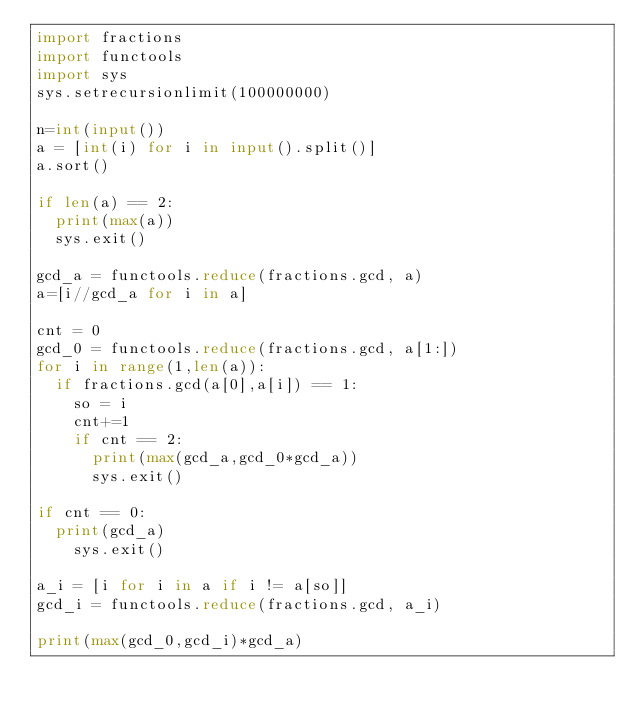<code> <loc_0><loc_0><loc_500><loc_500><_Python_>import fractions
import functools
import sys
sys.setrecursionlimit(100000000)

n=int(input())
a = [int(i) for i in input().split()]
a.sort()

if len(a) == 2:
  print(max(a))
  sys.exit()
  
gcd_a = functools.reduce(fractions.gcd, a)
a=[i//gcd_a for i in a]

cnt = 0
gcd_0 = functools.reduce(fractions.gcd, a[1:])
for i in range(1,len(a)):
  if fractions.gcd(a[0],a[i]) == 1:
    so = i
    cnt+=1
    if cnt == 2:
      print(max(gcd_a,gcd_0*gcd_a))
      sys.exit()
      
if cnt == 0:
  print(gcd_a)
    sys.exit()

a_i = [i for i in a if i != a[so]]
gcd_i = functools.reduce(fractions.gcd, a_i)

print(max(gcd_0,gcd_i)*gcd_a)
   </code> 